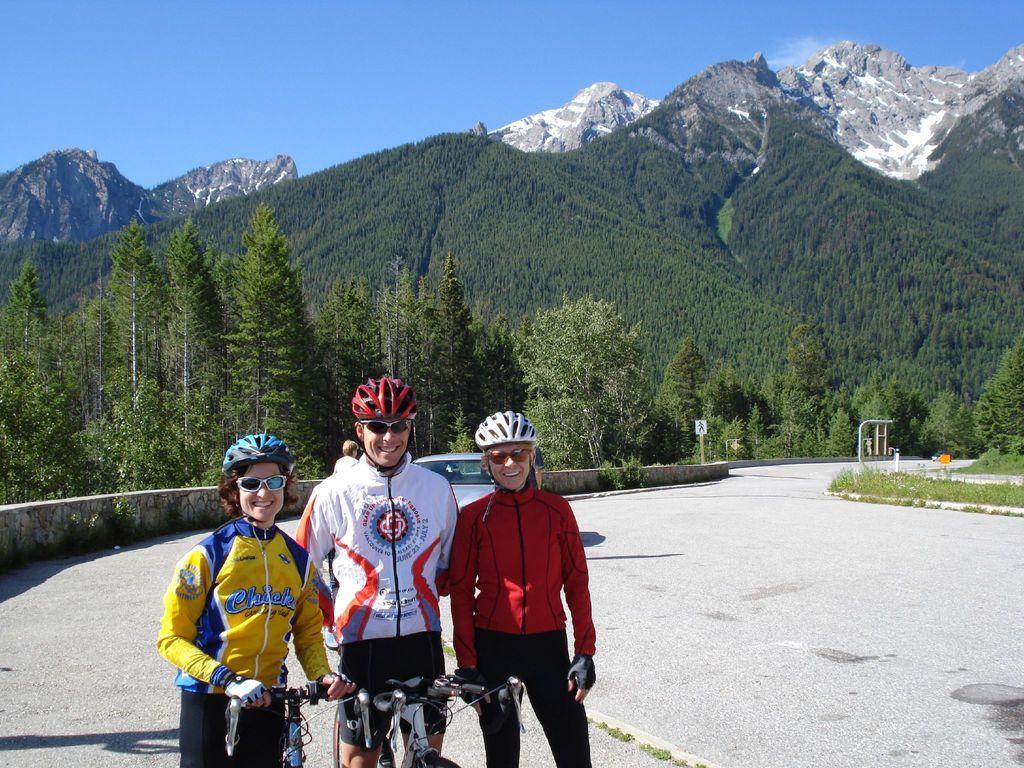Can you describe this image briefly? In this picture I can see few are standing and holding couple of bicycles and they are wearing helmets and sunglasses and I can see a car, a human, few trees and hills in the back and I can see a sign board, few plants and a blue sky. 